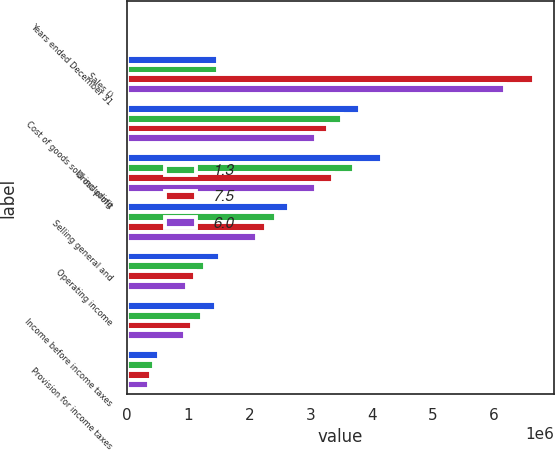<chart> <loc_0><loc_0><loc_500><loc_500><stacked_bar_chart><ecel><fcel>Years ended December 31<fcel>Sales ()<fcel>Cost of goods sold including<fcel>Gross profit<fcel>Selling general and<fcel>Operating income<fcel>Income before income taxes<fcel>Provision for income taxes<nl><fcel>nan<fcel>2015<fcel>1.48719e+06<fcel>3.80403e+06<fcel>4.16264e+06<fcel>2.64862e+06<fcel>1.51402e+06<fcel>1.46037e+06<fcel>529150<nl><fcel>1.3<fcel>2014<fcel>1.48719e+06<fcel>3.50718e+06<fcel>3.7089e+06<fcel>2.43853e+06<fcel>1.27037e+06<fcel>1.22218e+06<fcel>444000<nl><fcel>7.5<fcel>2013<fcel>6.64924e+06<fcel>3.28024e+06<fcel>3.369e+06<fcel>2.26552e+06<fcel>1.10348e+06<fcel>1.05894e+06<fcel>388650<nl><fcel>6<fcel>2012<fcel>6.18218e+06<fcel>3.08477e+06<fcel>3.09742e+06<fcel>2.12002e+06<fcel>977393<fcel>941521<fcel>355775<nl></chart> 